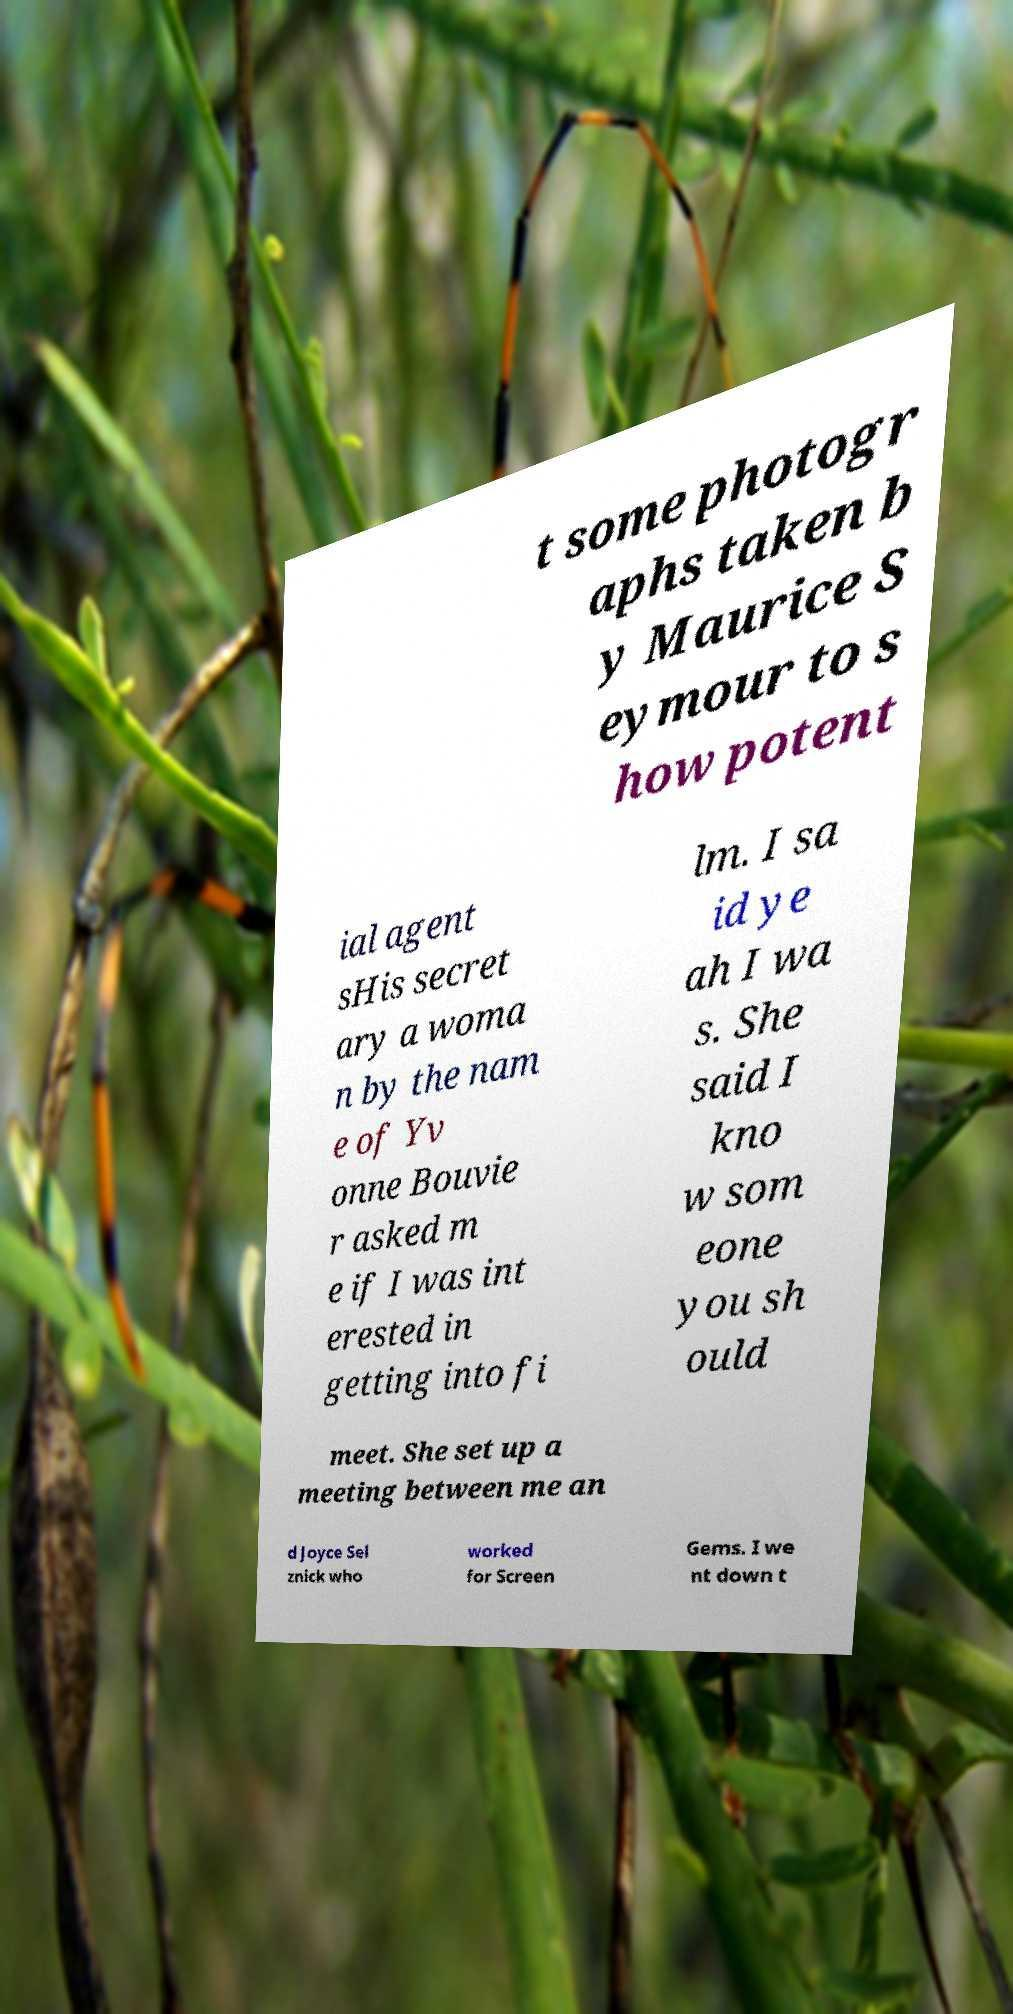Please read and relay the text visible in this image. What does it say? t some photogr aphs taken b y Maurice S eymour to s how potent ial agent sHis secret ary a woma n by the nam e of Yv onne Bouvie r asked m e if I was int erested in getting into fi lm. I sa id ye ah I wa s. She said I kno w som eone you sh ould meet. She set up a meeting between me an d Joyce Sel znick who worked for Screen Gems. I we nt down t 